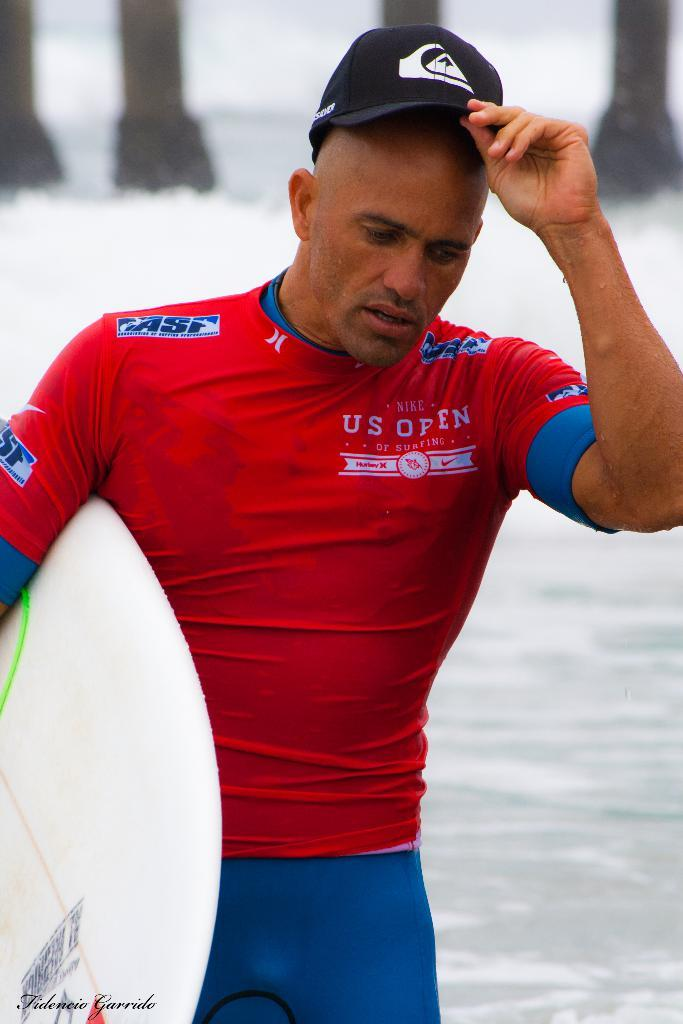<image>
Render a clear and concise summary of the photo. A man wears a red shirt for "Nike US Open of Surfing." 